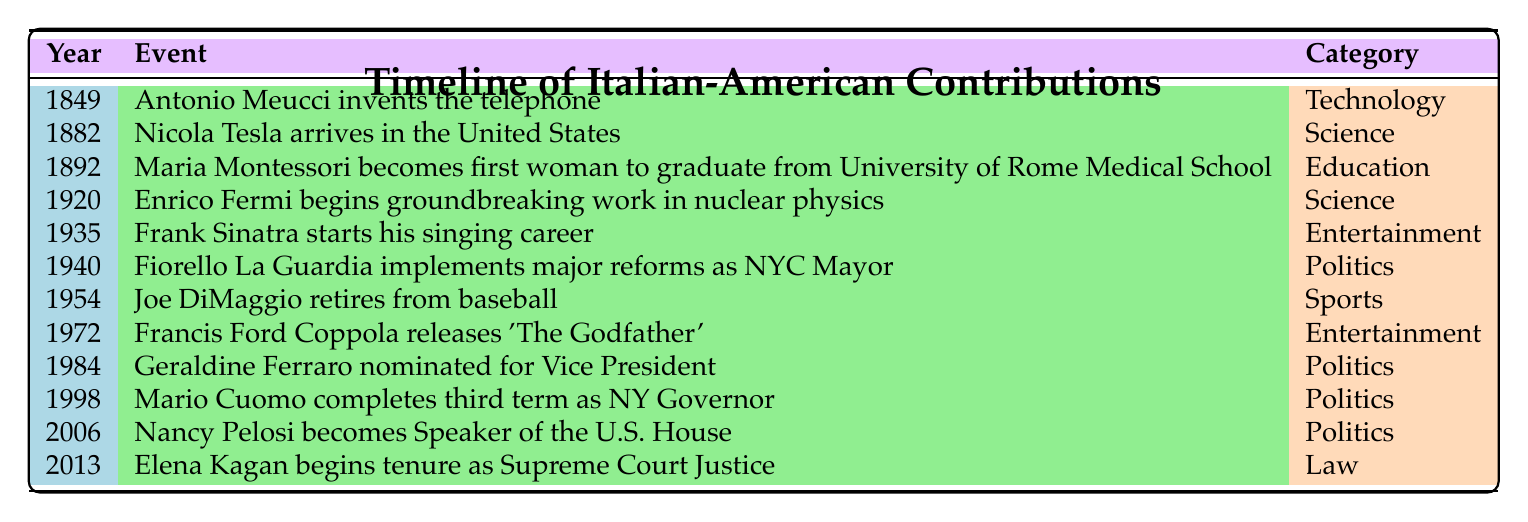What year did Antonio Meucci invent the telephone? The table states that Antonio Meucci invented the telephone in the year 1849.
Answer: 1849 Who started their singing career in 1935? According to the table, Frank Sinatra started his singing career in the year 1935.
Answer: Frank Sinatra How many events are listed in the 20th century (1900-1999)? The events listed in the table for the 20th century include: 1935 (Frank Sinatra), 1940 (Fiorello La Guardia), 1954 (Joe DiMaggio), 1972 (Francis Ford Coppola), 1984 (Geraldine Ferraro), and 1998 (Mario Cuomo). That's a total of 6 events.
Answer: 6 Is there any Italian-American who became a Supreme Court Justice according to the table? Yes, Elena Kagan, who is of Italian descent, is listed as beginning her tenure as Associate Justice of the Supreme Court in 2013.
Answer: Yes What was the earliest recorded event in the timeline? The earliest event recorded in the timeline is from the year 1849 when Antonio Meucci invented the telephone.
Answer: 1849 What is the difference in years between the events of Geraldine Ferraro's nomination for Vice President and Joe DiMaggio's retirement from baseball? Geraldine Ferraro was nominated in 1984, and Joe DiMaggio retired in 1954. The difference is 1984 - 1954 = 30 years.
Answer: 30 years Which category has the most entries in the timeline? The Politics category has four entries (Fiorello La Guardia in 1940, Geraldine Ferraro in 1984, Mario Cuomo in 1998, and Nancy Pelosi in 2006), which is more than any other category.
Answer: Politics How many individuals contributed to the field of Science according to the table? The table lists two events in the Science category: Nicola Tesla in 1882 and Enrico Fermi in 1920. Therefore, there are two individuals who contributed to Science.
Answer: 2 Did any events related to Education occur after 1900? Yes, Maria Montessori's achievement in the field of education occurred in 1892, which is before 1900. However, there are no later entries in Education after 1900 as her event is the only one.
Answer: No 